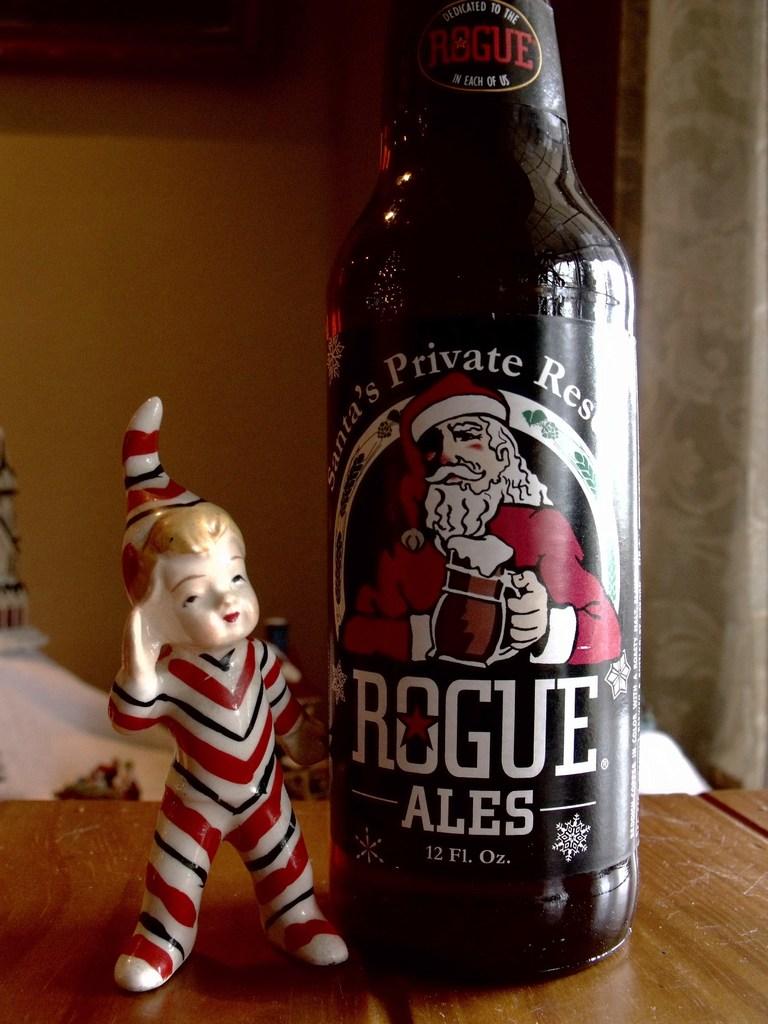How many ounces?
Offer a very short reply. 12. What brand of beer is this?
Offer a terse response. Rogue ales. 